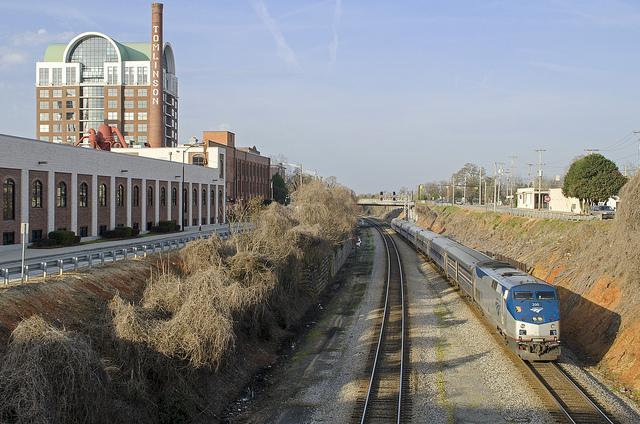What is the name of the smoke stack?
Short answer required. Tomlinson. Is this a steam engine?
Concise answer only. No. How many trains are pictured?
Concise answer only. 1. Is there a light on the train?
Short answer required. Yes. 